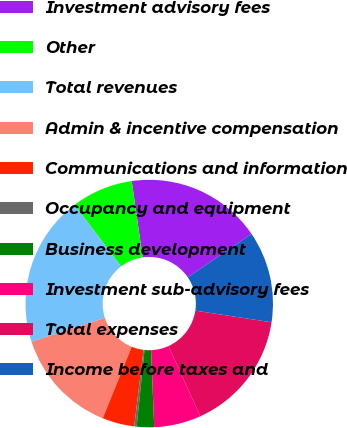<chart> <loc_0><loc_0><loc_500><loc_500><pie_chart><fcel>Investment advisory fees<fcel>Other<fcel>Total revenues<fcel>Admin & incentive compensation<fcel>Communications and information<fcel>Occupancy and equipment<fcel>Business development<fcel>Investment sub-advisory fees<fcel>Total expenses<fcel>Income before taxes and<nl><fcel>17.74%<fcel>8.06%<fcel>19.68%<fcel>13.87%<fcel>4.19%<fcel>0.32%<fcel>2.26%<fcel>6.13%<fcel>15.81%<fcel>11.94%<nl></chart> 